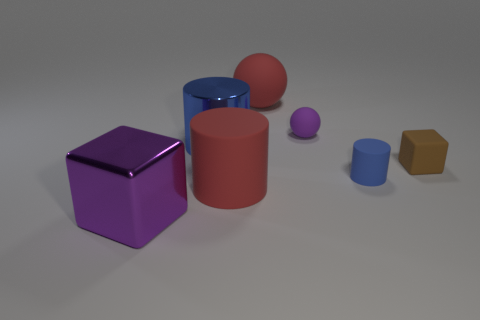There is a large red thing to the right of the red rubber cylinder; what is its shape? sphere 